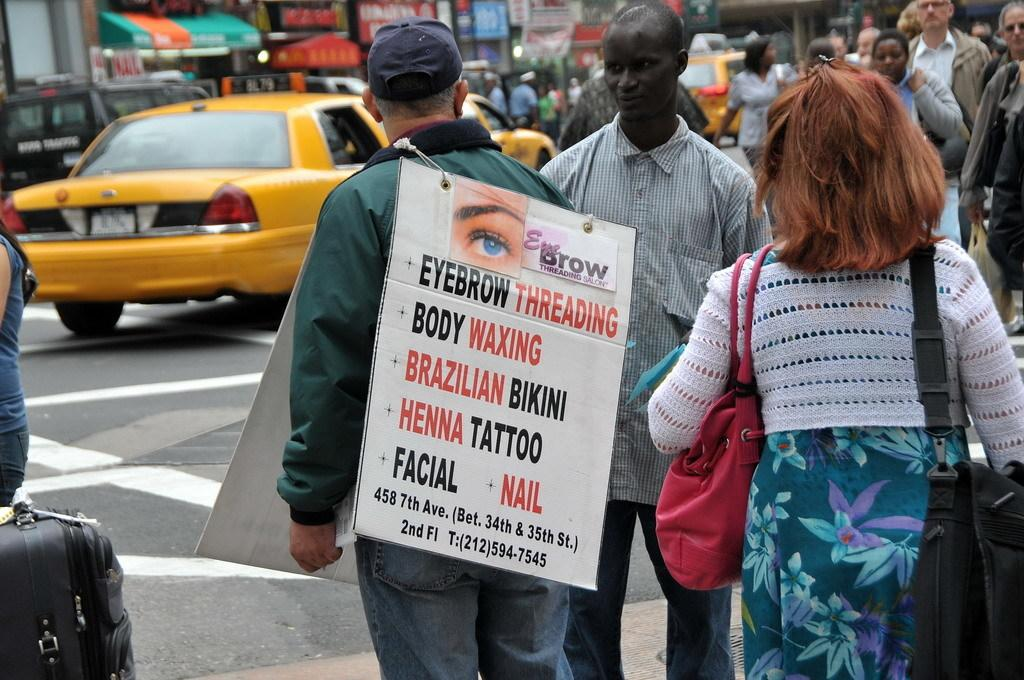<image>
Present a compact description of the photo's key features. A sign with a list of physical triats like henna tattoo and facial nail is hanging off the back of a man. 